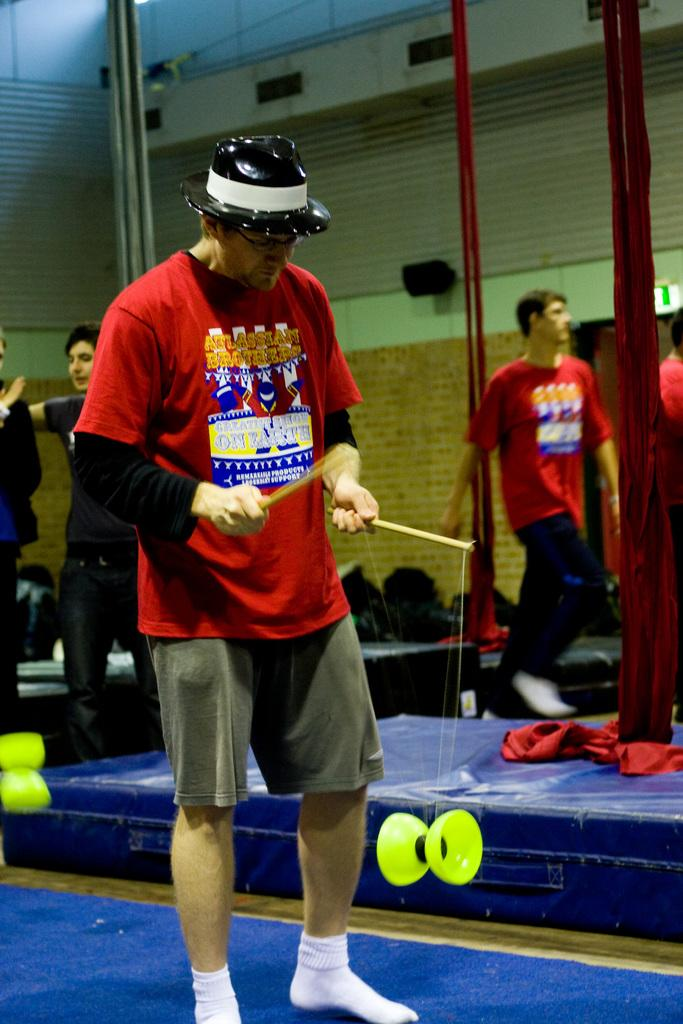What is happening in the image? There are people standing in the image. Can you describe any specific actions or objects being held by the people in the image? A man is holding a stick in his hand. Are there any bears visible in the image? No, there are no bears present in the image. Can you see any ducks swimming in the water near the people? No, there is no water or ducks visible in the image. 